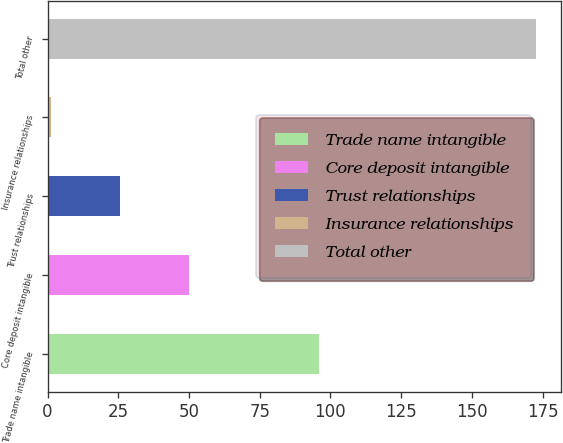<chart> <loc_0><loc_0><loc_500><loc_500><bar_chart><fcel>Trade name intangible<fcel>Core deposit intangible<fcel>Trust relationships<fcel>Insurance relationships<fcel>Total other<nl><fcel>96<fcel>49.9<fcel>25.6<fcel>1.3<fcel>172.8<nl></chart> 